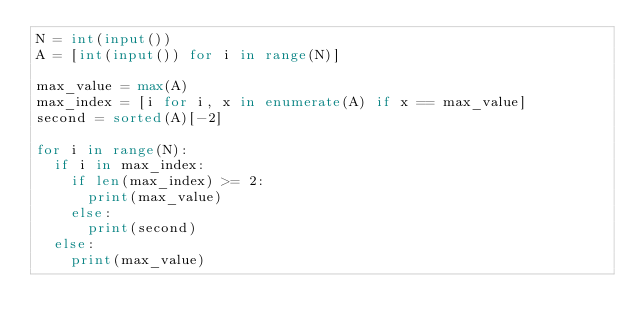Convert code to text. <code><loc_0><loc_0><loc_500><loc_500><_Python_>N = int(input())
A = [int(input()) for i in range(N)]

max_value = max(A)
max_index = [i for i, x in enumerate(A) if x == max_value]
second = sorted(A)[-2]

for i in range(N):
  if i in max_index:
    if len(max_index) >= 2:
      print(max_value)
    else:
      print(second)
  else:
    print(max_value)

</code> 